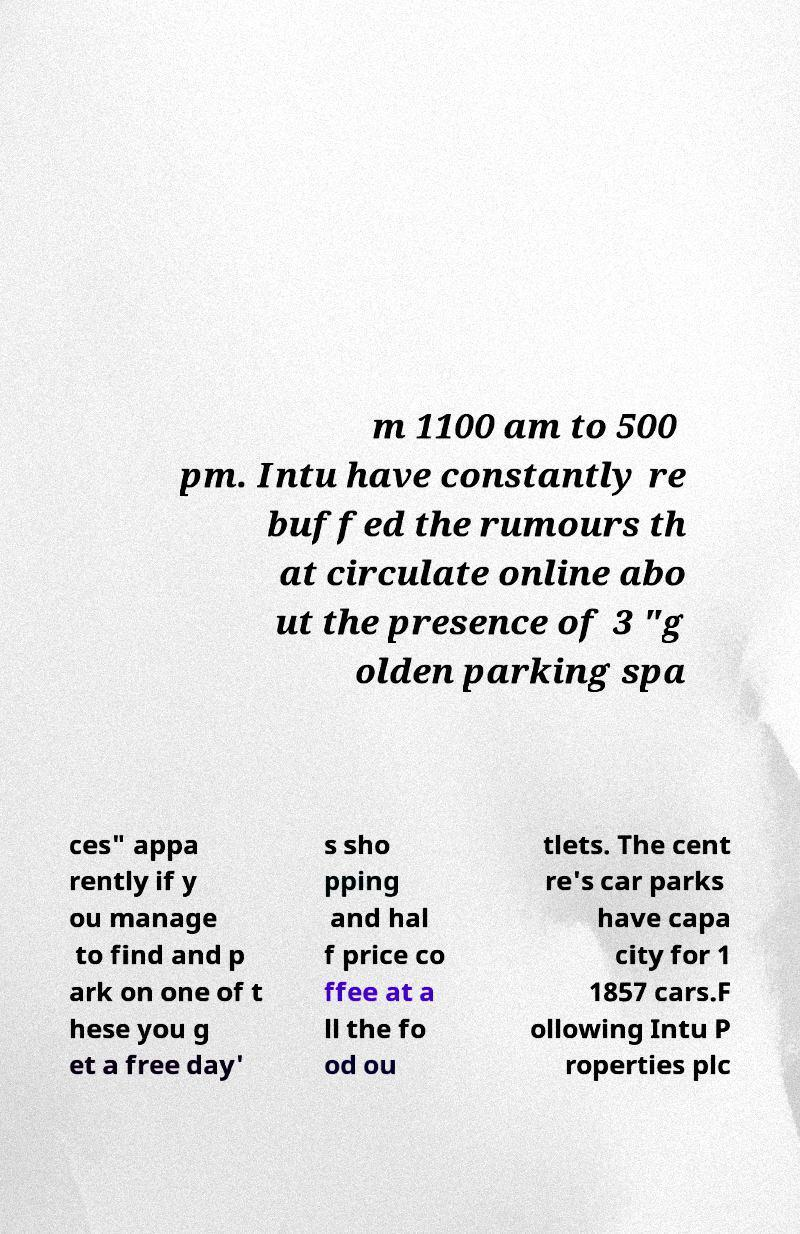What messages or text are displayed in this image? I need them in a readable, typed format. m 1100 am to 500 pm. Intu have constantly re buffed the rumours th at circulate online abo ut the presence of 3 "g olden parking spa ces" appa rently if y ou manage to find and p ark on one of t hese you g et a free day' s sho pping and hal f price co ffee at a ll the fo od ou tlets. The cent re's car parks have capa city for 1 1857 cars.F ollowing Intu P roperties plc 